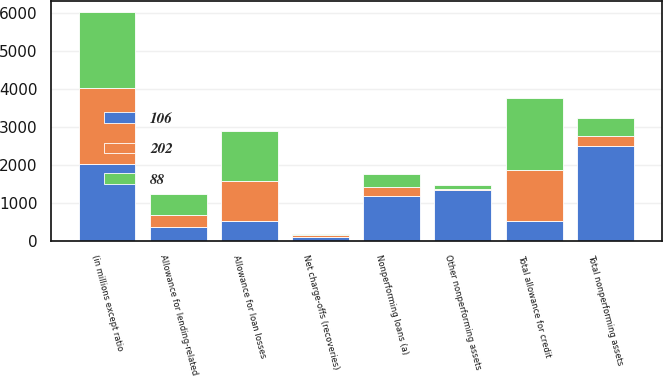Convert chart to OTSL. <chart><loc_0><loc_0><loc_500><loc_500><stacked_bar_chart><ecel><fcel>(in millions except ratio<fcel>Net charge-offs (recoveries)<fcel>Nonperforming loans (a)<fcel>Other nonperforming assets<fcel>Total nonperforming assets<fcel>Allowance for loan losses<fcel>Allowance for lending-related<fcel>Total allowance for credit<nl><fcel>106<fcel>2008<fcel>105<fcel>1175<fcel>1326<fcel>2501<fcel>506.5<fcel>360<fcel>506.5<nl><fcel>88<fcel>2007<fcel>36<fcel>353<fcel>100<fcel>453<fcel>1329<fcel>560<fcel>1889<nl><fcel>202<fcel>2006<fcel>31<fcel>231<fcel>38<fcel>269<fcel>1052<fcel>305<fcel>1357<nl></chart> 